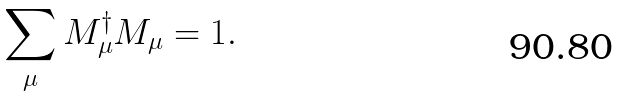<formula> <loc_0><loc_0><loc_500><loc_500>\sum _ { \mu } M _ { \mu } ^ { \dag } M _ { \mu } = 1 .</formula> 